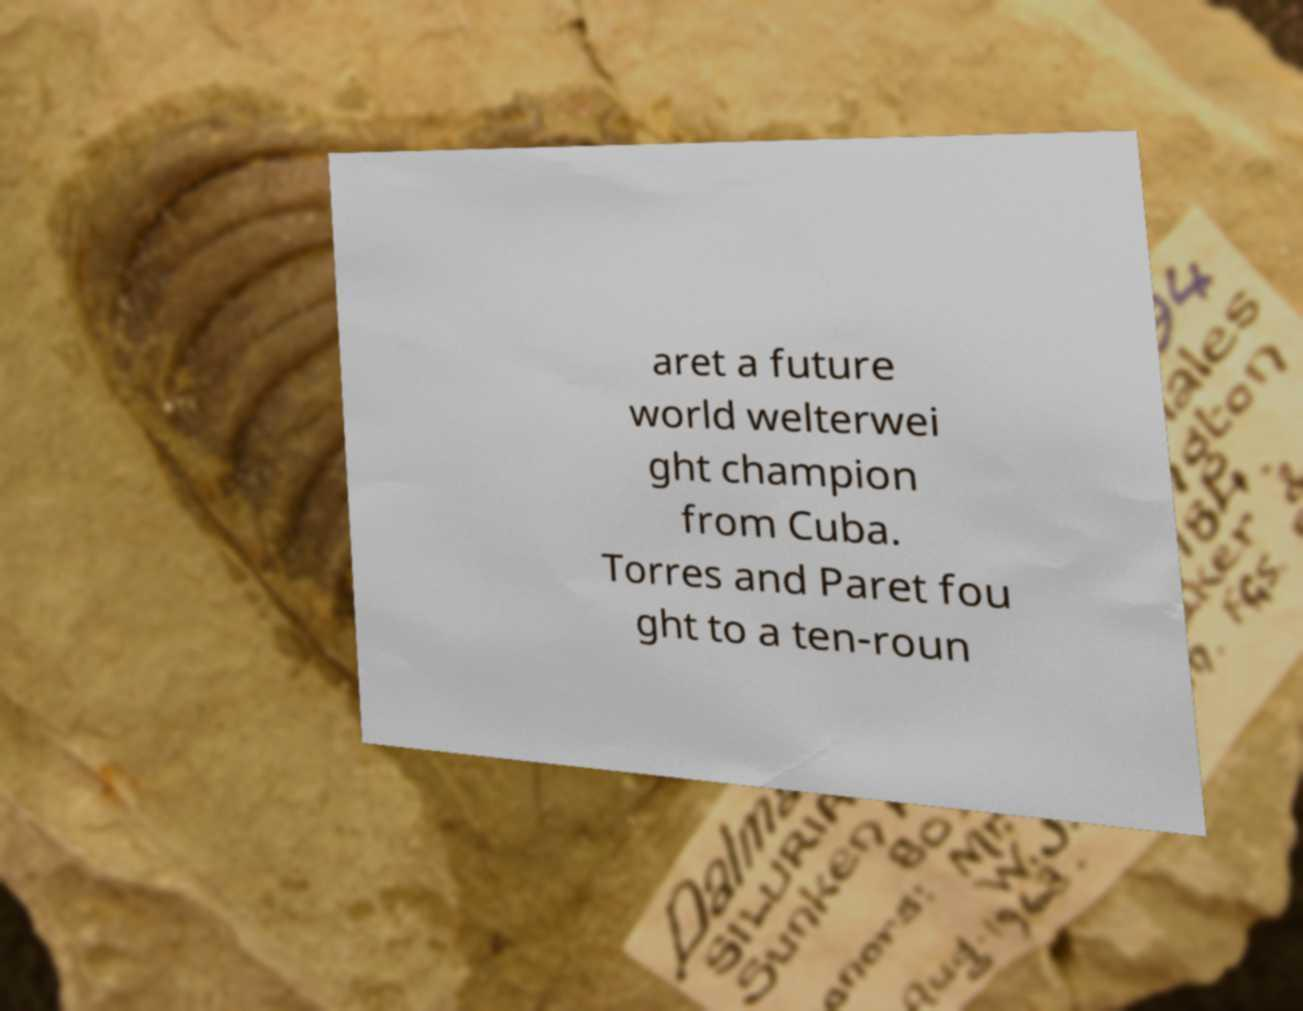What messages or text are displayed in this image? I need them in a readable, typed format. aret a future world welterwei ght champion from Cuba. Torres and Paret fou ght to a ten-roun 